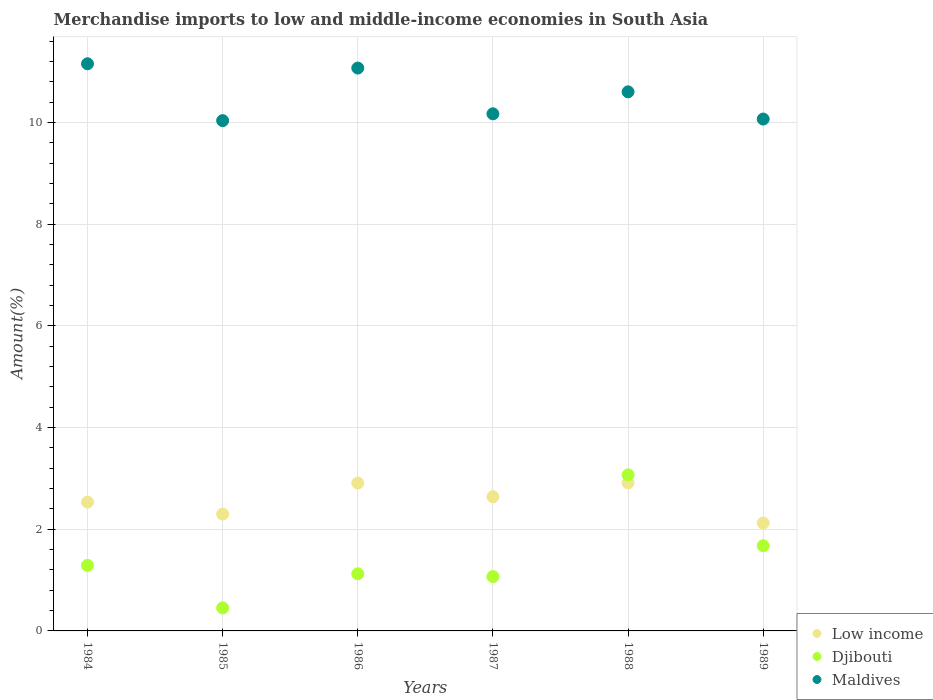Is the number of dotlines equal to the number of legend labels?
Provide a short and direct response. Yes. What is the percentage of amount earned from merchandise imports in Djibouti in 1989?
Your response must be concise. 1.68. Across all years, what is the maximum percentage of amount earned from merchandise imports in Djibouti?
Ensure brevity in your answer.  3.07. Across all years, what is the minimum percentage of amount earned from merchandise imports in Low income?
Your response must be concise. 2.12. In which year was the percentage of amount earned from merchandise imports in Maldives maximum?
Your answer should be very brief. 1984. In which year was the percentage of amount earned from merchandise imports in Djibouti minimum?
Your answer should be compact. 1985. What is the total percentage of amount earned from merchandise imports in Maldives in the graph?
Provide a short and direct response. 63.09. What is the difference between the percentage of amount earned from merchandise imports in Maldives in 1984 and that in 1987?
Offer a terse response. 0.98. What is the difference between the percentage of amount earned from merchandise imports in Maldives in 1984 and the percentage of amount earned from merchandise imports in Djibouti in 1986?
Offer a terse response. 10.03. What is the average percentage of amount earned from merchandise imports in Low income per year?
Provide a short and direct response. 2.57. In the year 1989, what is the difference between the percentage of amount earned from merchandise imports in Maldives and percentage of amount earned from merchandise imports in Djibouti?
Offer a very short reply. 8.39. In how many years, is the percentage of amount earned from merchandise imports in Maldives greater than 8 %?
Provide a succinct answer. 6. What is the ratio of the percentage of amount earned from merchandise imports in Low income in 1987 to that in 1989?
Provide a succinct answer. 1.24. Is the difference between the percentage of amount earned from merchandise imports in Maldives in 1985 and 1986 greater than the difference between the percentage of amount earned from merchandise imports in Djibouti in 1985 and 1986?
Keep it short and to the point. No. What is the difference between the highest and the second highest percentage of amount earned from merchandise imports in Maldives?
Make the answer very short. 0.08. What is the difference between the highest and the lowest percentage of amount earned from merchandise imports in Djibouti?
Provide a short and direct response. 2.62. Is the sum of the percentage of amount earned from merchandise imports in Maldives in 1985 and 1989 greater than the maximum percentage of amount earned from merchandise imports in Low income across all years?
Ensure brevity in your answer.  Yes. Is it the case that in every year, the sum of the percentage of amount earned from merchandise imports in Low income and percentage of amount earned from merchandise imports in Maldives  is greater than the percentage of amount earned from merchandise imports in Djibouti?
Your answer should be compact. Yes. Does the percentage of amount earned from merchandise imports in Djibouti monotonically increase over the years?
Provide a short and direct response. No. Is the percentage of amount earned from merchandise imports in Maldives strictly less than the percentage of amount earned from merchandise imports in Djibouti over the years?
Make the answer very short. No. How many dotlines are there?
Your answer should be compact. 3. What is the difference between two consecutive major ticks on the Y-axis?
Make the answer very short. 2. Does the graph contain any zero values?
Offer a terse response. No. Does the graph contain grids?
Ensure brevity in your answer.  Yes. How many legend labels are there?
Provide a succinct answer. 3. How are the legend labels stacked?
Your response must be concise. Vertical. What is the title of the graph?
Keep it short and to the point. Merchandise imports to low and middle-income economies in South Asia. What is the label or title of the Y-axis?
Offer a very short reply. Amount(%). What is the Amount(%) in Low income in 1984?
Give a very brief answer. 2.53. What is the Amount(%) in Djibouti in 1984?
Keep it short and to the point. 1.29. What is the Amount(%) of Maldives in 1984?
Offer a terse response. 11.15. What is the Amount(%) in Low income in 1985?
Offer a terse response. 2.3. What is the Amount(%) in Djibouti in 1985?
Ensure brevity in your answer.  0.45. What is the Amount(%) of Maldives in 1985?
Give a very brief answer. 10.04. What is the Amount(%) in Low income in 1986?
Give a very brief answer. 2.91. What is the Amount(%) of Djibouti in 1986?
Your answer should be very brief. 1.12. What is the Amount(%) in Maldives in 1986?
Provide a succinct answer. 11.07. What is the Amount(%) of Low income in 1987?
Give a very brief answer. 2.64. What is the Amount(%) of Djibouti in 1987?
Your answer should be very brief. 1.07. What is the Amount(%) in Maldives in 1987?
Provide a succinct answer. 10.17. What is the Amount(%) of Low income in 1988?
Provide a succinct answer. 2.91. What is the Amount(%) of Djibouti in 1988?
Your answer should be compact. 3.07. What is the Amount(%) in Maldives in 1988?
Provide a succinct answer. 10.6. What is the Amount(%) of Low income in 1989?
Keep it short and to the point. 2.12. What is the Amount(%) of Djibouti in 1989?
Give a very brief answer. 1.68. What is the Amount(%) in Maldives in 1989?
Keep it short and to the point. 10.07. Across all years, what is the maximum Amount(%) in Low income?
Your answer should be compact. 2.91. Across all years, what is the maximum Amount(%) in Djibouti?
Provide a succinct answer. 3.07. Across all years, what is the maximum Amount(%) of Maldives?
Keep it short and to the point. 11.15. Across all years, what is the minimum Amount(%) of Low income?
Your answer should be compact. 2.12. Across all years, what is the minimum Amount(%) of Djibouti?
Make the answer very short. 0.45. Across all years, what is the minimum Amount(%) in Maldives?
Your answer should be very brief. 10.04. What is the total Amount(%) in Low income in the graph?
Provide a succinct answer. 15.41. What is the total Amount(%) of Djibouti in the graph?
Your answer should be compact. 8.68. What is the total Amount(%) in Maldives in the graph?
Your answer should be very brief. 63.09. What is the difference between the Amount(%) of Low income in 1984 and that in 1985?
Your response must be concise. 0.24. What is the difference between the Amount(%) of Djibouti in 1984 and that in 1985?
Offer a terse response. 0.84. What is the difference between the Amount(%) in Maldives in 1984 and that in 1985?
Your answer should be compact. 1.12. What is the difference between the Amount(%) of Low income in 1984 and that in 1986?
Your answer should be very brief. -0.37. What is the difference between the Amount(%) in Djibouti in 1984 and that in 1986?
Provide a short and direct response. 0.17. What is the difference between the Amount(%) of Maldives in 1984 and that in 1986?
Provide a succinct answer. 0.08. What is the difference between the Amount(%) in Low income in 1984 and that in 1987?
Keep it short and to the point. -0.11. What is the difference between the Amount(%) in Djibouti in 1984 and that in 1987?
Make the answer very short. 0.22. What is the difference between the Amount(%) of Maldives in 1984 and that in 1987?
Make the answer very short. 0.98. What is the difference between the Amount(%) in Low income in 1984 and that in 1988?
Your answer should be compact. -0.38. What is the difference between the Amount(%) in Djibouti in 1984 and that in 1988?
Your response must be concise. -1.78. What is the difference between the Amount(%) of Maldives in 1984 and that in 1988?
Make the answer very short. 0.55. What is the difference between the Amount(%) in Low income in 1984 and that in 1989?
Your answer should be compact. 0.41. What is the difference between the Amount(%) in Djibouti in 1984 and that in 1989?
Offer a very short reply. -0.39. What is the difference between the Amount(%) in Maldives in 1984 and that in 1989?
Offer a terse response. 1.09. What is the difference between the Amount(%) in Low income in 1985 and that in 1986?
Offer a very short reply. -0.61. What is the difference between the Amount(%) of Djibouti in 1985 and that in 1986?
Offer a very short reply. -0.67. What is the difference between the Amount(%) of Maldives in 1985 and that in 1986?
Give a very brief answer. -1.03. What is the difference between the Amount(%) of Low income in 1985 and that in 1987?
Make the answer very short. -0.34. What is the difference between the Amount(%) of Djibouti in 1985 and that in 1987?
Your answer should be compact. -0.62. What is the difference between the Amount(%) in Maldives in 1985 and that in 1987?
Give a very brief answer. -0.13. What is the difference between the Amount(%) in Low income in 1985 and that in 1988?
Keep it short and to the point. -0.61. What is the difference between the Amount(%) in Djibouti in 1985 and that in 1988?
Provide a short and direct response. -2.62. What is the difference between the Amount(%) of Maldives in 1985 and that in 1988?
Provide a short and direct response. -0.57. What is the difference between the Amount(%) in Low income in 1985 and that in 1989?
Provide a succinct answer. 0.17. What is the difference between the Amount(%) in Djibouti in 1985 and that in 1989?
Your answer should be compact. -1.22. What is the difference between the Amount(%) of Maldives in 1985 and that in 1989?
Your answer should be compact. -0.03. What is the difference between the Amount(%) in Low income in 1986 and that in 1987?
Offer a terse response. 0.27. What is the difference between the Amount(%) of Djibouti in 1986 and that in 1987?
Provide a short and direct response. 0.05. What is the difference between the Amount(%) in Maldives in 1986 and that in 1987?
Your answer should be compact. 0.9. What is the difference between the Amount(%) in Low income in 1986 and that in 1988?
Your answer should be compact. -0. What is the difference between the Amount(%) of Djibouti in 1986 and that in 1988?
Keep it short and to the point. -1.95. What is the difference between the Amount(%) in Maldives in 1986 and that in 1988?
Provide a short and direct response. 0.47. What is the difference between the Amount(%) in Low income in 1986 and that in 1989?
Offer a very short reply. 0.78. What is the difference between the Amount(%) of Djibouti in 1986 and that in 1989?
Your response must be concise. -0.55. What is the difference between the Amount(%) in Maldives in 1986 and that in 1989?
Offer a very short reply. 1. What is the difference between the Amount(%) of Low income in 1987 and that in 1988?
Your answer should be compact. -0.27. What is the difference between the Amount(%) in Djibouti in 1987 and that in 1988?
Your response must be concise. -2. What is the difference between the Amount(%) in Maldives in 1987 and that in 1988?
Keep it short and to the point. -0.43. What is the difference between the Amount(%) in Low income in 1987 and that in 1989?
Ensure brevity in your answer.  0.52. What is the difference between the Amount(%) of Djibouti in 1987 and that in 1989?
Provide a succinct answer. -0.61. What is the difference between the Amount(%) of Maldives in 1987 and that in 1989?
Keep it short and to the point. 0.1. What is the difference between the Amount(%) of Low income in 1988 and that in 1989?
Give a very brief answer. 0.79. What is the difference between the Amount(%) of Djibouti in 1988 and that in 1989?
Ensure brevity in your answer.  1.39. What is the difference between the Amount(%) of Maldives in 1988 and that in 1989?
Offer a terse response. 0.54. What is the difference between the Amount(%) of Low income in 1984 and the Amount(%) of Djibouti in 1985?
Offer a terse response. 2.08. What is the difference between the Amount(%) of Low income in 1984 and the Amount(%) of Maldives in 1985?
Offer a terse response. -7.5. What is the difference between the Amount(%) in Djibouti in 1984 and the Amount(%) in Maldives in 1985?
Ensure brevity in your answer.  -8.75. What is the difference between the Amount(%) of Low income in 1984 and the Amount(%) of Djibouti in 1986?
Ensure brevity in your answer.  1.41. What is the difference between the Amount(%) in Low income in 1984 and the Amount(%) in Maldives in 1986?
Your response must be concise. -8.54. What is the difference between the Amount(%) of Djibouti in 1984 and the Amount(%) of Maldives in 1986?
Ensure brevity in your answer.  -9.78. What is the difference between the Amount(%) of Low income in 1984 and the Amount(%) of Djibouti in 1987?
Give a very brief answer. 1.46. What is the difference between the Amount(%) in Low income in 1984 and the Amount(%) in Maldives in 1987?
Your answer should be compact. -7.64. What is the difference between the Amount(%) of Djibouti in 1984 and the Amount(%) of Maldives in 1987?
Keep it short and to the point. -8.88. What is the difference between the Amount(%) in Low income in 1984 and the Amount(%) in Djibouti in 1988?
Provide a succinct answer. -0.54. What is the difference between the Amount(%) in Low income in 1984 and the Amount(%) in Maldives in 1988?
Offer a terse response. -8.07. What is the difference between the Amount(%) in Djibouti in 1984 and the Amount(%) in Maldives in 1988?
Your answer should be very brief. -9.31. What is the difference between the Amount(%) of Low income in 1984 and the Amount(%) of Djibouti in 1989?
Your answer should be compact. 0.86. What is the difference between the Amount(%) in Low income in 1984 and the Amount(%) in Maldives in 1989?
Give a very brief answer. -7.53. What is the difference between the Amount(%) of Djibouti in 1984 and the Amount(%) of Maldives in 1989?
Your answer should be compact. -8.78. What is the difference between the Amount(%) in Low income in 1985 and the Amount(%) in Djibouti in 1986?
Ensure brevity in your answer.  1.17. What is the difference between the Amount(%) in Low income in 1985 and the Amount(%) in Maldives in 1986?
Give a very brief answer. -8.77. What is the difference between the Amount(%) in Djibouti in 1985 and the Amount(%) in Maldives in 1986?
Ensure brevity in your answer.  -10.62. What is the difference between the Amount(%) in Low income in 1985 and the Amount(%) in Djibouti in 1987?
Your answer should be very brief. 1.23. What is the difference between the Amount(%) of Low income in 1985 and the Amount(%) of Maldives in 1987?
Make the answer very short. -7.87. What is the difference between the Amount(%) of Djibouti in 1985 and the Amount(%) of Maldives in 1987?
Give a very brief answer. -9.72. What is the difference between the Amount(%) of Low income in 1985 and the Amount(%) of Djibouti in 1988?
Make the answer very short. -0.77. What is the difference between the Amount(%) in Low income in 1985 and the Amount(%) in Maldives in 1988?
Offer a terse response. -8.3. What is the difference between the Amount(%) of Djibouti in 1985 and the Amount(%) of Maldives in 1988?
Offer a terse response. -10.15. What is the difference between the Amount(%) of Low income in 1985 and the Amount(%) of Djibouti in 1989?
Ensure brevity in your answer.  0.62. What is the difference between the Amount(%) of Low income in 1985 and the Amount(%) of Maldives in 1989?
Give a very brief answer. -7.77. What is the difference between the Amount(%) in Djibouti in 1985 and the Amount(%) in Maldives in 1989?
Make the answer very short. -9.61. What is the difference between the Amount(%) of Low income in 1986 and the Amount(%) of Djibouti in 1987?
Your response must be concise. 1.84. What is the difference between the Amount(%) of Low income in 1986 and the Amount(%) of Maldives in 1987?
Offer a terse response. -7.26. What is the difference between the Amount(%) in Djibouti in 1986 and the Amount(%) in Maldives in 1987?
Offer a very short reply. -9.05. What is the difference between the Amount(%) of Low income in 1986 and the Amount(%) of Djibouti in 1988?
Provide a short and direct response. -0.16. What is the difference between the Amount(%) of Low income in 1986 and the Amount(%) of Maldives in 1988?
Your answer should be very brief. -7.69. What is the difference between the Amount(%) in Djibouti in 1986 and the Amount(%) in Maldives in 1988?
Provide a short and direct response. -9.48. What is the difference between the Amount(%) of Low income in 1986 and the Amount(%) of Djibouti in 1989?
Your answer should be compact. 1.23. What is the difference between the Amount(%) of Low income in 1986 and the Amount(%) of Maldives in 1989?
Your response must be concise. -7.16. What is the difference between the Amount(%) in Djibouti in 1986 and the Amount(%) in Maldives in 1989?
Give a very brief answer. -8.94. What is the difference between the Amount(%) in Low income in 1987 and the Amount(%) in Djibouti in 1988?
Your response must be concise. -0.43. What is the difference between the Amount(%) in Low income in 1987 and the Amount(%) in Maldives in 1988?
Give a very brief answer. -7.96. What is the difference between the Amount(%) of Djibouti in 1987 and the Amount(%) of Maldives in 1988?
Your answer should be very brief. -9.53. What is the difference between the Amount(%) of Low income in 1987 and the Amount(%) of Djibouti in 1989?
Your response must be concise. 0.96. What is the difference between the Amount(%) in Low income in 1987 and the Amount(%) in Maldives in 1989?
Give a very brief answer. -7.43. What is the difference between the Amount(%) in Djibouti in 1987 and the Amount(%) in Maldives in 1989?
Your answer should be very brief. -9. What is the difference between the Amount(%) of Low income in 1988 and the Amount(%) of Djibouti in 1989?
Make the answer very short. 1.23. What is the difference between the Amount(%) of Low income in 1988 and the Amount(%) of Maldives in 1989?
Offer a terse response. -7.16. What is the difference between the Amount(%) of Djibouti in 1988 and the Amount(%) of Maldives in 1989?
Offer a terse response. -7. What is the average Amount(%) in Low income per year?
Give a very brief answer. 2.57. What is the average Amount(%) in Djibouti per year?
Provide a short and direct response. 1.45. What is the average Amount(%) in Maldives per year?
Give a very brief answer. 10.52. In the year 1984, what is the difference between the Amount(%) in Low income and Amount(%) in Djibouti?
Your answer should be very brief. 1.24. In the year 1984, what is the difference between the Amount(%) of Low income and Amount(%) of Maldives?
Provide a short and direct response. -8.62. In the year 1984, what is the difference between the Amount(%) of Djibouti and Amount(%) of Maldives?
Provide a succinct answer. -9.86. In the year 1985, what is the difference between the Amount(%) of Low income and Amount(%) of Djibouti?
Keep it short and to the point. 1.84. In the year 1985, what is the difference between the Amount(%) in Low income and Amount(%) in Maldives?
Keep it short and to the point. -7.74. In the year 1985, what is the difference between the Amount(%) of Djibouti and Amount(%) of Maldives?
Ensure brevity in your answer.  -9.58. In the year 1986, what is the difference between the Amount(%) in Low income and Amount(%) in Djibouti?
Make the answer very short. 1.78. In the year 1986, what is the difference between the Amount(%) of Low income and Amount(%) of Maldives?
Offer a terse response. -8.16. In the year 1986, what is the difference between the Amount(%) of Djibouti and Amount(%) of Maldives?
Keep it short and to the point. -9.95. In the year 1987, what is the difference between the Amount(%) in Low income and Amount(%) in Djibouti?
Your answer should be compact. 1.57. In the year 1987, what is the difference between the Amount(%) of Low income and Amount(%) of Maldives?
Make the answer very short. -7.53. In the year 1987, what is the difference between the Amount(%) in Djibouti and Amount(%) in Maldives?
Give a very brief answer. -9.1. In the year 1988, what is the difference between the Amount(%) in Low income and Amount(%) in Djibouti?
Ensure brevity in your answer.  -0.16. In the year 1988, what is the difference between the Amount(%) of Low income and Amount(%) of Maldives?
Provide a succinct answer. -7.69. In the year 1988, what is the difference between the Amount(%) in Djibouti and Amount(%) in Maldives?
Provide a short and direct response. -7.53. In the year 1989, what is the difference between the Amount(%) in Low income and Amount(%) in Djibouti?
Your answer should be compact. 0.45. In the year 1989, what is the difference between the Amount(%) in Low income and Amount(%) in Maldives?
Provide a succinct answer. -7.94. In the year 1989, what is the difference between the Amount(%) in Djibouti and Amount(%) in Maldives?
Keep it short and to the point. -8.39. What is the ratio of the Amount(%) of Low income in 1984 to that in 1985?
Your answer should be compact. 1.1. What is the ratio of the Amount(%) of Djibouti in 1984 to that in 1985?
Ensure brevity in your answer.  2.85. What is the ratio of the Amount(%) of Maldives in 1984 to that in 1985?
Keep it short and to the point. 1.11. What is the ratio of the Amount(%) in Low income in 1984 to that in 1986?
Give a very brief answer. 0.87. What is the ratio of the Amount(%) of Djibouti in 1984 to that in 1986?
Offer a terse response. 1.15. What is the ratio of the Amount(%) in Maldives in 1984 to that in 1986?
Give a very brief answer. 1.01. What is the ratio of the Amount(%) in Low income in 1984 to that in 1987?
Keep it short and to the point. 0.96. What is the ratio of the Amount(%) in Djibouti in 1984 to that in 1987?
Keep it short and to the point. 1.21. What is the ratio of the Amount(%) in Maldives in 1984 to that in 1987?
Make the answer very short. 1.1. What is the ratio of the Amount(%) of Low income in 1984 to that in 1988?
Make the answer very short. 0.87. What is the ratio of the Amount(%) in Djibouti in 1984 to that in 1988?
Ensure brevity in your answer.  0.42. What is the ratio of the Amount(%) of Maldives in 1984 to that in 1988?
Ensure brevity in your answer.  1.05. What is the ratio of the Amount(%) of Low income in 1984 to that in 1989?
Your answer should be compact. 1.19. What is the ratio of the Amount(%) in Djibouti in 1984 to that in 1989?
Keep it short and to the point. 0.77. What is the ratio of the Amount(%) in Maldives in 1984 to that in 1989?
Provide a succinct answer. 1.11. What is the ratio of the Amount(%) in Low income in 1985 to that in 1986?
Provide a short and direct response. 0.79. What is the ratio of the Amount(%) of Djibouti in 1985 to that in 1986?
Ensure brevity in your answer.  0.4. What is the ratio of the Amount(%) of Maldives in 1985 to that in 1986?
Make the answer very short. 0.91. What is the ratio of the Amount(%) of Low income in 1985 to that in 1987?
Your answer should be very brief. 0.87. What is the ratio of the Amount(%) of Djibouti in 1985 to that in 1987?
Offer a terse response. 0.42. What is the ratio of the Amount(%) of Maldives in 1985 to that in 1987?
Provide a succinct answer. 0.99. What is the ratio of the Amount(%) of Low income in 1985 to that in 1988?
Provide a short and direct response. 0.79. What is the ratio of the Amount(%) in Djibouti in 1985 to that in 1988?
Your answer should be very brief. 0.15. What is the ratio of the Amount(%) of Maldives in 1985 to that in 1988?
Make the answer very short. 0.95. What is the ratio of the Amount(%) of Low income in 1985 to that in 1989?
Provide a short and direct response. 1.08. What is the ratio of the Amount(%) of Djibouti in 1985 to that in 1989?
Provide a short and direct response. 0.27. What is the ratio of the Amount(%) of Maldives in 1985 to that in 1989?
Make the answer very short. 1. What is the ratio of the Amount(%) of Low income in 1986 to that in 1987?
Your response must be concise. 1.1. What is the ratio of the Amount(%) in Djibouti in 1986 to that in 1987?
Ensure brevity in your answer.  1.05. What is the ratio of the Amount(%) in Maldives in 1986 to that in 1987?
Your answer should be very brief. 1.09. What is the ratio of the Amount(%) of Djibouti in 1986 to that in 1988?
Offer a very short reply. 0.37. What is the ratio of the Amount(%) in Maldives in 1986 to that in 1988?
Keep it short and to the point. 1.04. What is the ratio of the Amount(%) of Low income in 1986 to that in 1989?
Your answer should be very brief. 1.37. What is the ratio of the Amount(%) in Djibouti in 1986 to that in 1989?
Your answer should be compact. 0.67. What is the ratio of the Amount(%) of Maldives in 1986 to that in 1989?
Your answer should be very brief. 1.1. What is the ratio of the Amount(%) in Low income in 1987 to that in 1988?
Make the answer very short. 0.91. What is the ratio of the Amount(%) in Djibouti in 1987 to that in 1988?
Give a very brief answer. 0.35. What is the ratio of the Amount(%) of Maldives in 1987 to that in 1988?
Offer a terse response. 0.96. What is the ratio of the Amount(%) in Low income in 1987 to that in 1989?
Provide a short and direct response. 1.24. What is the ratio of the Amount(%) of Djibouti in 1987 to that in 1989?
Offer a very short reply. 0.64. What is the ratio of the Amount(%) of Maldives in 1987 to that in 1989?
Your response must be concise. 1.01. What is the ratio of the Amount(%) of Low income in 1988 to that in 1989?
Your response must be concise. 1.37. What is the ratio of the Amount(%) in Djibouti in 1988 to that in 1989?
Give a very brief answer. 1.83. What is the ratio of the Amount(%) in Maldives in 1988 to that in 1989?
Offer a very short reply. 1.05. What is the difference between the highest and the second highest Amount(%) in Low income?
Offer a very short reply. 0. What is the difference between the highest and the second highest Amount(%) of Djibouti?
Ensure brevity in your answer.  1.39. What is the difference between the highest and the second highest Amount(%) in Maldives?
Provide a succinct answer. 0.08. What is the difference between the highest and the lowest Amount(%) in Low income?
Give a very brief answer. 0.79. What is the difference between the highest and the lowest Amount(%) of Djibouti?
Your answer should be very brief. 2.62. What is the difference between the highest and the lowest Amount(%) in Maldives?
Your response must be concise. 1.12. 